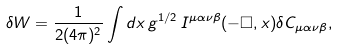<formula> <loc_0><loc_0><loc_500><loc_500>\delta W = \frac { 1 } { 2 ( 4 \pi ) ^ { 2 } } \int d x \, g ^ { 1 / 2 } \, I ^ { \mu \alpha \nu \beta } ( - \Box , x ) \delta C _ { \mu \alpha \nu \beta } ,</formula> 